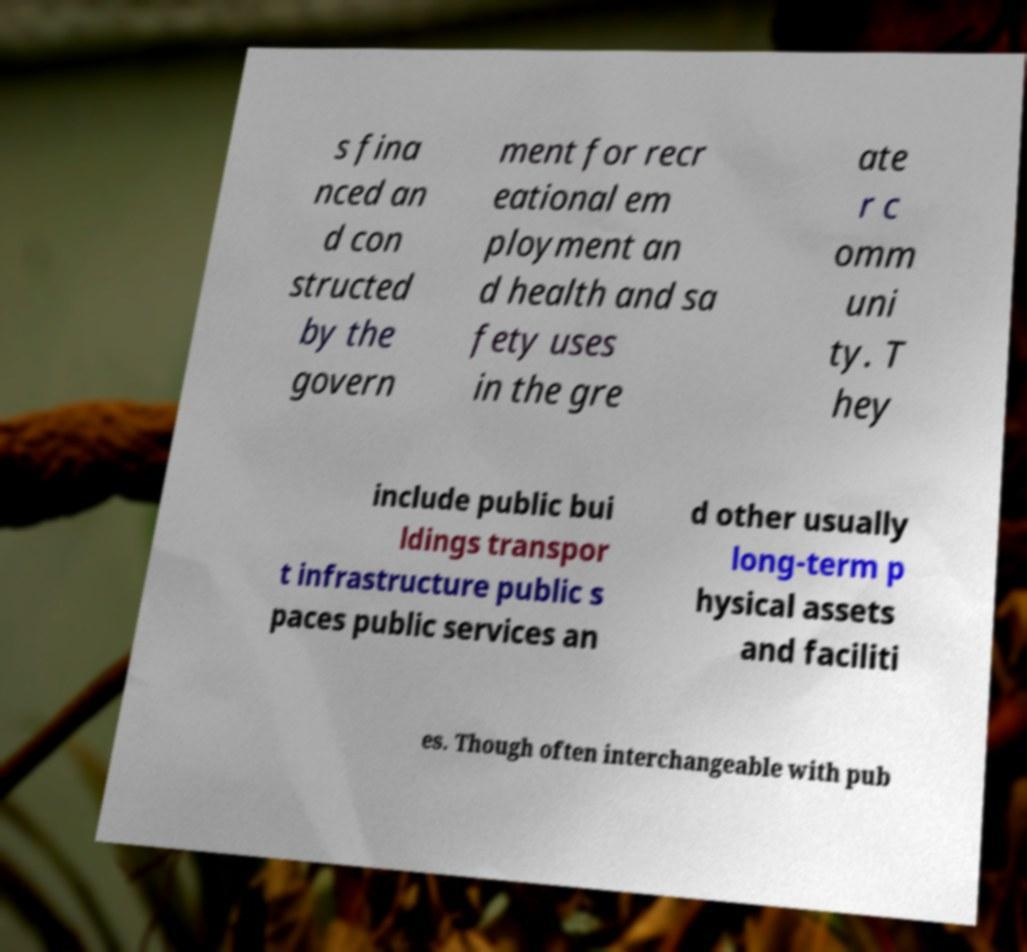I need the written content from this picture converted into text. Can you do that? s fina nced an d con structed by the govern ment for recr eational em ployment an d health and sa fety uses in the gre ate r c omm uni ty. T hey include public bui ldings transpor t infrastructure public s paces public services an d other usually long-term p hysical assets and faciliti es. Though often interchangeable with pub 